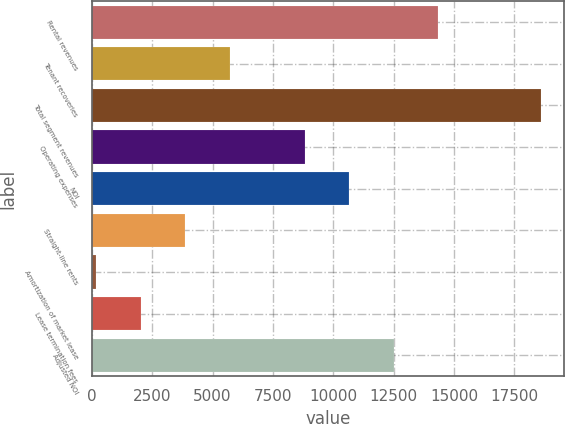Convert chart to OTSL. <chart><loc_0><loc_0><loc_500><loc_500><bar_chart><fcel>Rental revenues<fcel>Tenant recoveries<fcel>Total segment revenues<fcel>Operating expenses<fcel>NOI<fcel>Straight-line rents<fcel>Amortization of market lease<fcel>Lease termination fees<fcel>Adjusted NOI<nl><fcel>14356.8<fcel>5709.8<fcel>18622<fcel>8823<fcel>10667.6<fcel>3865.2<fcel>176<fcel>2020.6<fcel>12512.2<nl></chart> 